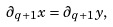<formula> <loc_0><loc_0><loc_500><loc_500>\partial _ { q + 1 } x = \partial _ { q + 1 } y ,</formula> 